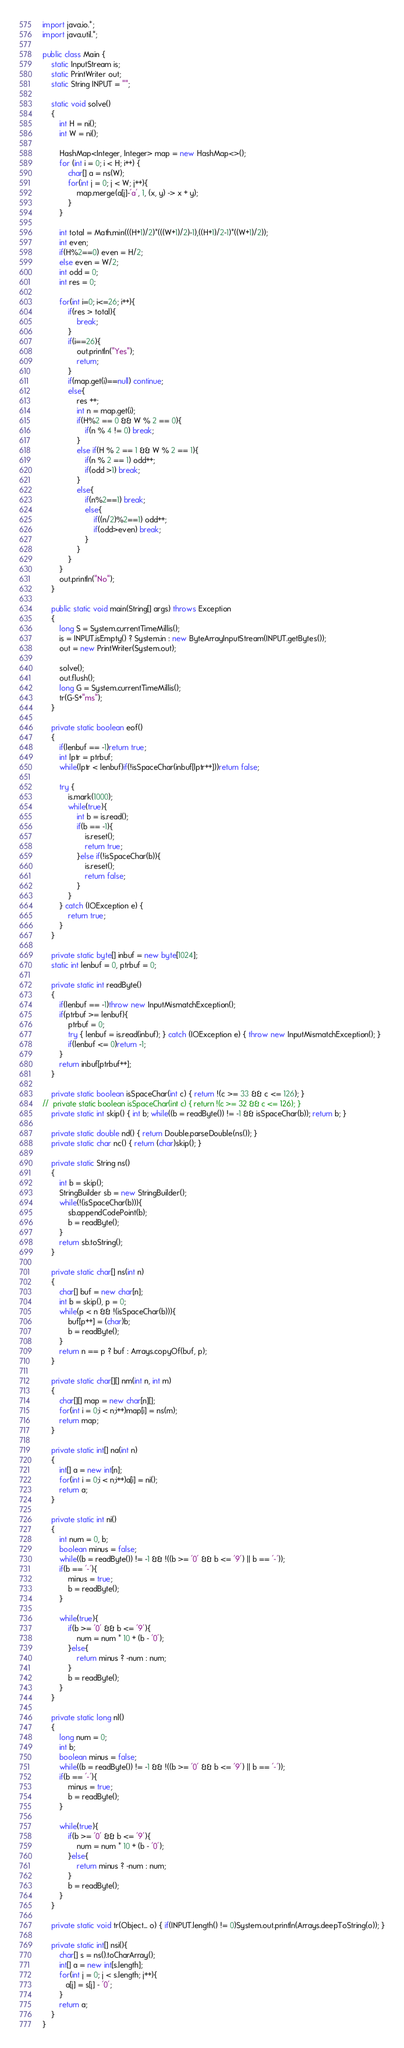Convert code to text. <code><loc_0><loc_0><loc_500><loc_500><_Java_>import java.io.*;
import java.util.*;

public class Main {
    static InputStream is;
    static PrintWriter out;
    static String INPUT = "";
    
    static void solve()
    {
        int H = ni();
        int W = ni();

        HashMap<Integer, Integer> map = new HashMap<>();
        for (int i = 0; i < H; i++) {
            char[] a = ns(W);
            for(int j = 0; j < W; j++){
                map.merge(a[j]-'a', 1, (x, y) -> x + y);
            }
        }

        int total = Math.min(((H+1)/2)*(((W+1)/2)-1),((H+1)/2-1)*((W+1)/2));
        int even;
        if(H%2==0) even = H/2;
        else even = W/2;
        int odd = 0;
        int res = 0;

        for(int i=0; i<=26; i++){
            if(res > total){
                break;
            }
            if(i==26){
                out.println("Yes");
                return;
            }
            if(map.get(i)==null) continue;
            else{
                res ++;
                int n = map.get(i);
                if(H%2 == 0 && W % 2 == 0){
                    if(n % 4 != 0) break;
                }
                else if(H % 2 == 1 && W % 2 == 1){
                    if(n % 2 == 1) odd++;
                    if(odd >1) break;
                }
                else{
                    if(n%2==1) break;
                    else{
                        if((n/2)%2==1) odd++;
                        if(odd>even) break;
                    }
                }
            }
        }
        out.println("No");
    }
    
    public static void main(String[] args) throws Exception
    {
        long S = System.currentTimeMillis();
        is = INPUT.isEmpty() ? System.in : new ByteArrayInputStream(INPUT.getBytes());
        out = new PrintWriter(System.out);
        
        solve();
        out.flush();
        long G = System.currentTimeMillis();
        tr(G-S+"ms");
    }
    
    private static boolean eof()
    {
        if(lenbuf == -1)return true;
        int lptr = ptrbuf;
        while(lptr < lenbuf)if(!isSpaceChar(inbuf[lptr++]))return false;
        
        try {
            is.mark(1000);
            while(true){
                int b = is.read();
                if(b == -1){
                    is.reset();
                    return true;
                }else if(!isSpaceChar(b)){
                    is.reset();
                    return false;
                }
            }
        } catch (IOException e) {
            return true;
        }
    }
    
    private static byte[] inbuf = new byte[1024];
    static int lenbuf = 0, ptrbuf = 0;
    
    private static int readByte()
    {
        if(lenbuf == -1)throw new InputMismatchException();
        if(ptrbuf >= lenbuf){
            ptrbuf = 0;
            try { lenbuf = is.read(inbuf); } catch (IOException e) { throw new InputMismatchException(); }
            if(lenbuf <= 0)return -1;
        }
        return inbuf[ptrbuf++];
    }
    
    private static boolean isSpaceChar(int c) { return !(c >= 33 && c <= 126); }
//  private static boolean isSpaceChar(int c) { return !(c >= 32 && c <= 126); }
    private static int skip() { int b; while((b = readByte()) != -1 && isSpaceChar(b)); return b; }
    
    private static double nd() { return Double.parseDouble(ns()); }
    private static char nc() { return (char)skip(); }
    
    private static String ns()
    {
        int b = skip();
        StringBuilder sb = new StringBuilder();
        while(!(isSpaceChar(b))){
            sb.appendCodePoint(b);
            b = readByte();
        }
        return sb.toString();
    }
    
    private static char[] ns(int n)
    {
        char[] buf = new char[n];
        int b = skip(), p = 0;
        while(p < n && !(isSpaceChar(b))){
            buf[p++] = (char)b;
            b = readByte();
        }
        return n == p ? buf : Arrays.copyOf(buf, p);
    }
    
    private static char[][] nm(int n, int m)
    {
        char[][] map = new char[n][];
        for(int i = 0;i < n;i++)map[i] = ns(m);
        return map;
    }
    
    private static int[] na(int n)
    {
        int[] a = new int[n];
        for(int i = 0;i < n;i++)a[i] = ni();
        return a;
    }
    
    private static int ni()
    {
        int num = 0, b;
        boolean minus = false;
        while((b = readByte()) != -1 && !((b >= '0' && b <= '9') || b == '-'));
        if(b == '-'){
            minus = true;
            b = readByte();
        }
        
        while(true){
            if(b >= '0' && b <= '9'){
                num = num * 10 + (b - '0');
            }else{
                return minus ? -num : num;
            }
            b = readByte();
        }
    }
    
    private static long nl()
    {
        long num = 0;
        int b;
        boolean minus = false;
        while((b = readByte()) != -1 && !((b >= '0' && b <= '9') || b == '-'));
        if(b == '-'){
            minus = true;
            b = readByte();
        }
        
        while(true){
            if(b >= '0' && b <= '9'){
                num = num * 10 + (b - '0');
            }else{
                return minus ? -num : num;
            }
            b = readByte();
        }
    }
    
    private static void tr(Object... o) { if(INPUT.length() != 0)System.out.println(Arrays.deepToString(o)); }

    private static int[] nsi(){
        char[] s = ns().toCharArray();
        int[] a = new int[s.length];
        for(int j = 0; j < s.length; j++){
           a[j] = s[j] - '0';
        }
        return a;
    }
}</code> 